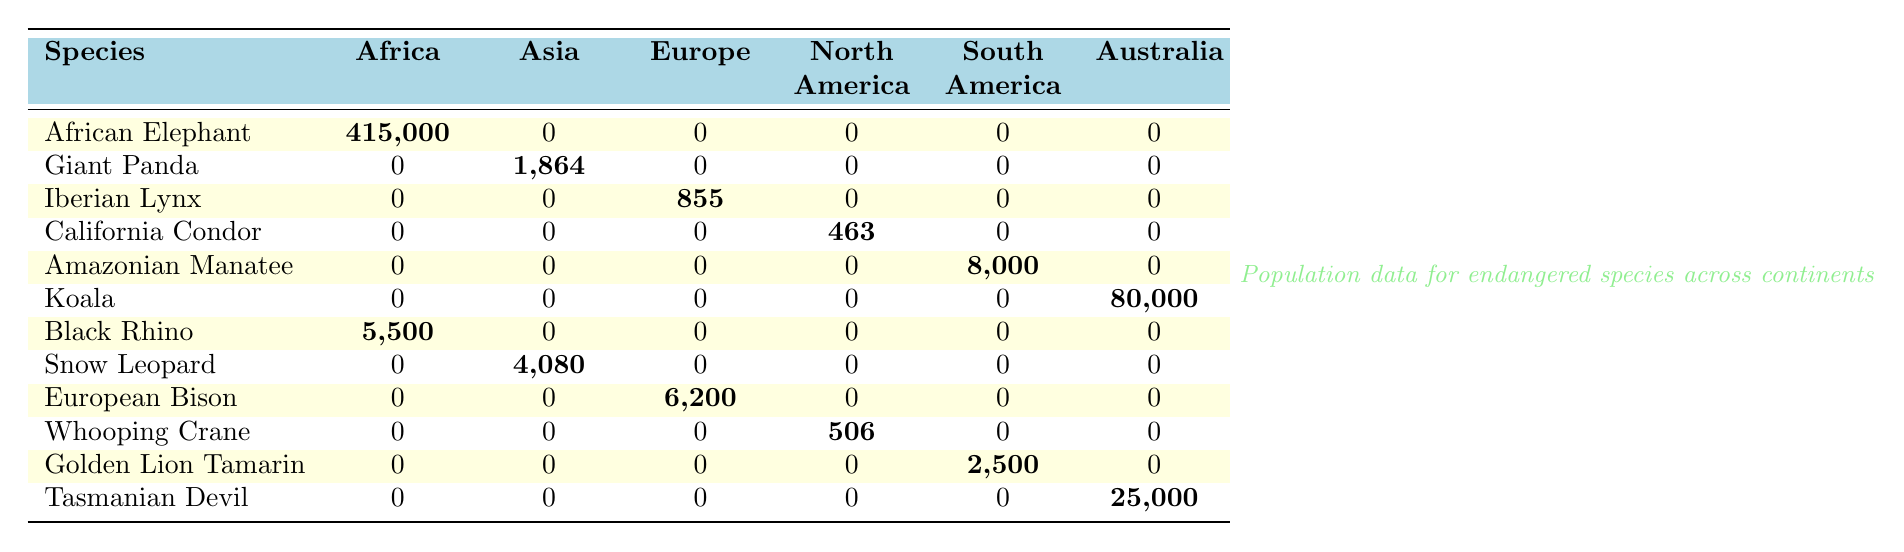What is the population of the African Elephant in Africa? The table shows that the population of the African Elephant in Africa is recorded as 415,000.
Answer: 415,000 How many species are found in Europe according to the table? Looking at the table, only the Iberian Lynx (855) and the European Bison (6,200) have populations listed under Europe, summing to 2 species.
Answer: 2 Is there any endangered species with a population greater than 80,000? Koala has a population of 80,000, which is equal to this number. Therefore, there is no species with a population greater than 80,000.
Answer: No What is the total population of endangered species in South America? The only species with a population recorded in South America are the Amazonian Manatee (8,000) and the Golden Lion Tamarin (2,500). Summing these gives 8,000 + 2,500 = 10,500.
Answer: 10,500 Which continent has the highest number of African Elephants? The only continent where African Elephants are listed is Africa, with a population of 415,000. No other continent has African Elephants.
Answer: Africa Calculate the total number of Black Rhinos and African Elephants combined in Africa. The population of Black Rhinos is 5,500 and African Elephants is 415,000 in Africa. Adding these values gives 5,500 + 415,000 = 420,500.
Answer: 420,500 Is the population of the Giant Panda in Asia greater than that of the Snow Leopard in Asia? The table shows 1,864 for Giant Panda and 4,080 for Snow Leopard. Since 4,080 is greater than 1,864, the claim is true.
Answer: Yes Which species has the least population in Europe? In Europe, the Iberian Lynx has a population of 855 and European Bison has 6,200. Since 855 is less than 6,200, the Iberian Lynx is the species with the least population in Europe.
Answer: Iberian Lynx What percentage of the total population of endangered species is represented by the South American species? The total populations in South America are 8,000 (Amazonian Manatee) + 2,500 (Golden Lion Tamarin) = 10,500. The overall total populations from all species is 415,000 + 1864 + 855 + 463 + 8,000 + 80,000 + 5,500 + 4,080 + 6,200 + 506 + 2,500 + 25,000 = 552,563, therefore, (10,500 / 552,563) * 100 ≈ 1.90%.
Answer: 1.90% What is the population of the Californian Condor compared to the Whooping Crane in North America? The table shows that the Californian Condor has a population of 463 while the Whooping Crane has a population of 506 in North America. Therefore, the Californian Condor has a lower population compared to the Whooping Crane.
Answer: Lower 